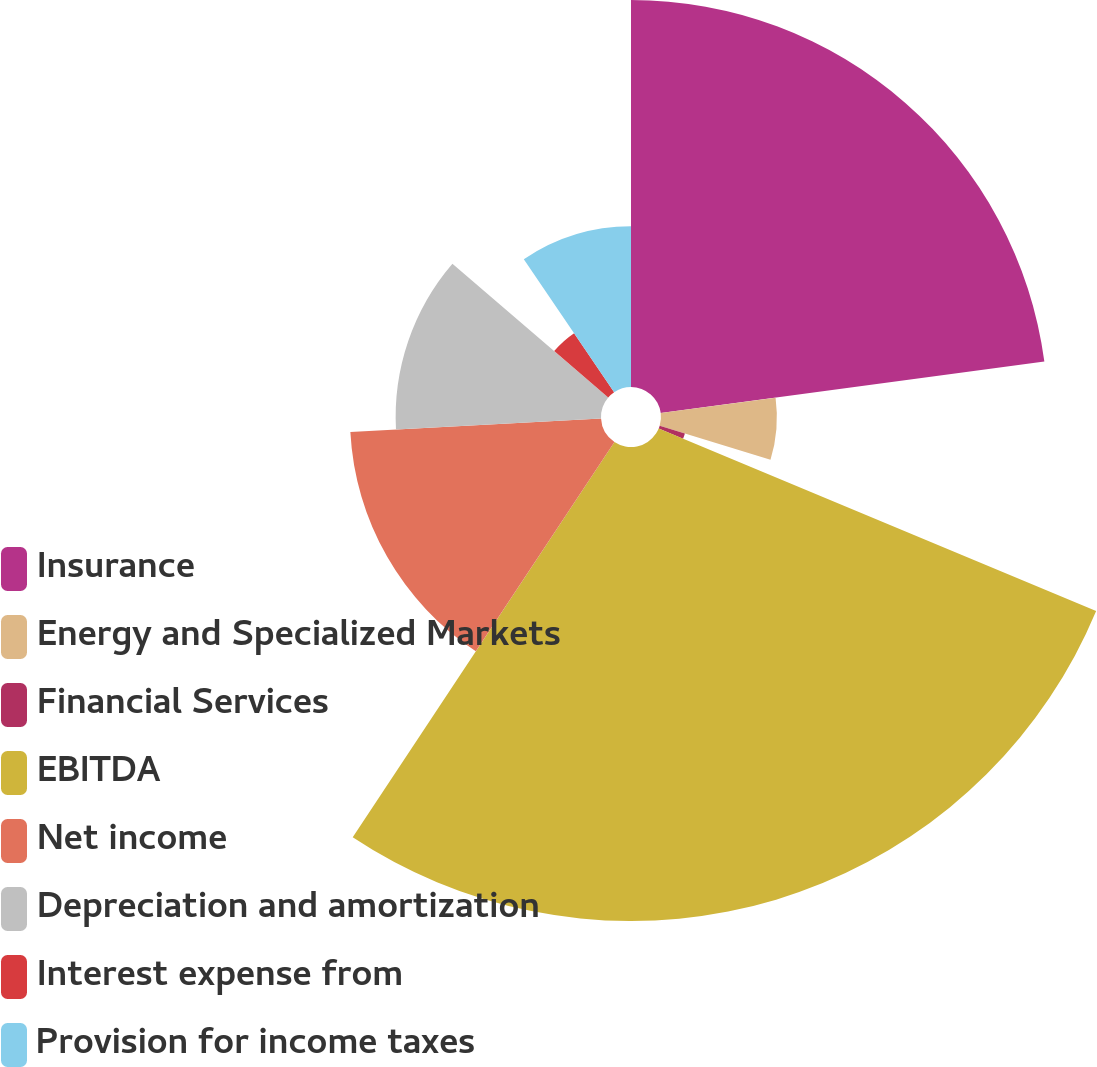Convert chart. <chart><loc_0><loc_0><loc_500><loc_500><pie_chart><fcel>Insurance<fcel>Energy and Specialized Markets<fcel>Financial Services<fcel>EBITDA<fcel>Net income<fcel>Depreciation and amortization<fcel>Interest expense from<fcel>Provision for income taxes<nl><fcel>22.88%<fcel>6.85%<fcel>1.56%<fcel>28.02%<fcel>14.84%<fcel>12.14%<fcel>4.21%<fcel>9.5%<nl></chart> 